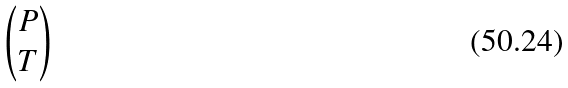Convert formula to latex. <formula><loc_0><loc_0><loc_500><loc_500>\begin{pmatrix} P \\ { T } \end{pmatrix}</formula> 